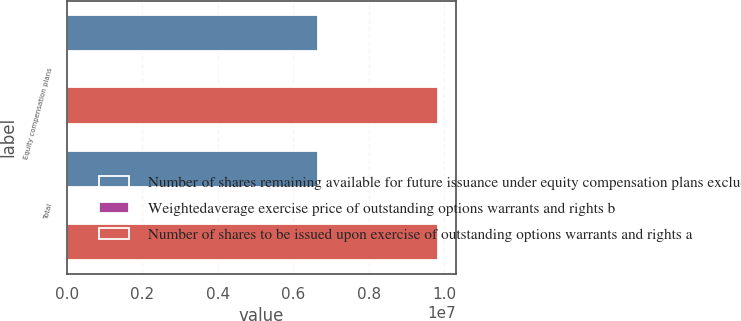Convert chart. <chart><loc_0><loc_0><loc_500><loc_500><stacked_bar_chart><ecel><fcel>Equity compensation plans<fcel>Total<nl><fcel>Number of shares remaining available for future issuance under equity compensation plans excluding shares reflected in column a c<fcel>6.66097e+06<fcel>6.66097e+06<nl><fcel>Weightedaverage exercise price of outstanding options warrants and rights b<fcel>20.01<fcel>20.01<nl><fcel>Number of shares to be issued upon exercise of outstanding options warrants and rights a<fcel>9.821e+06<fcel>9.821e+06<nl></chart> 